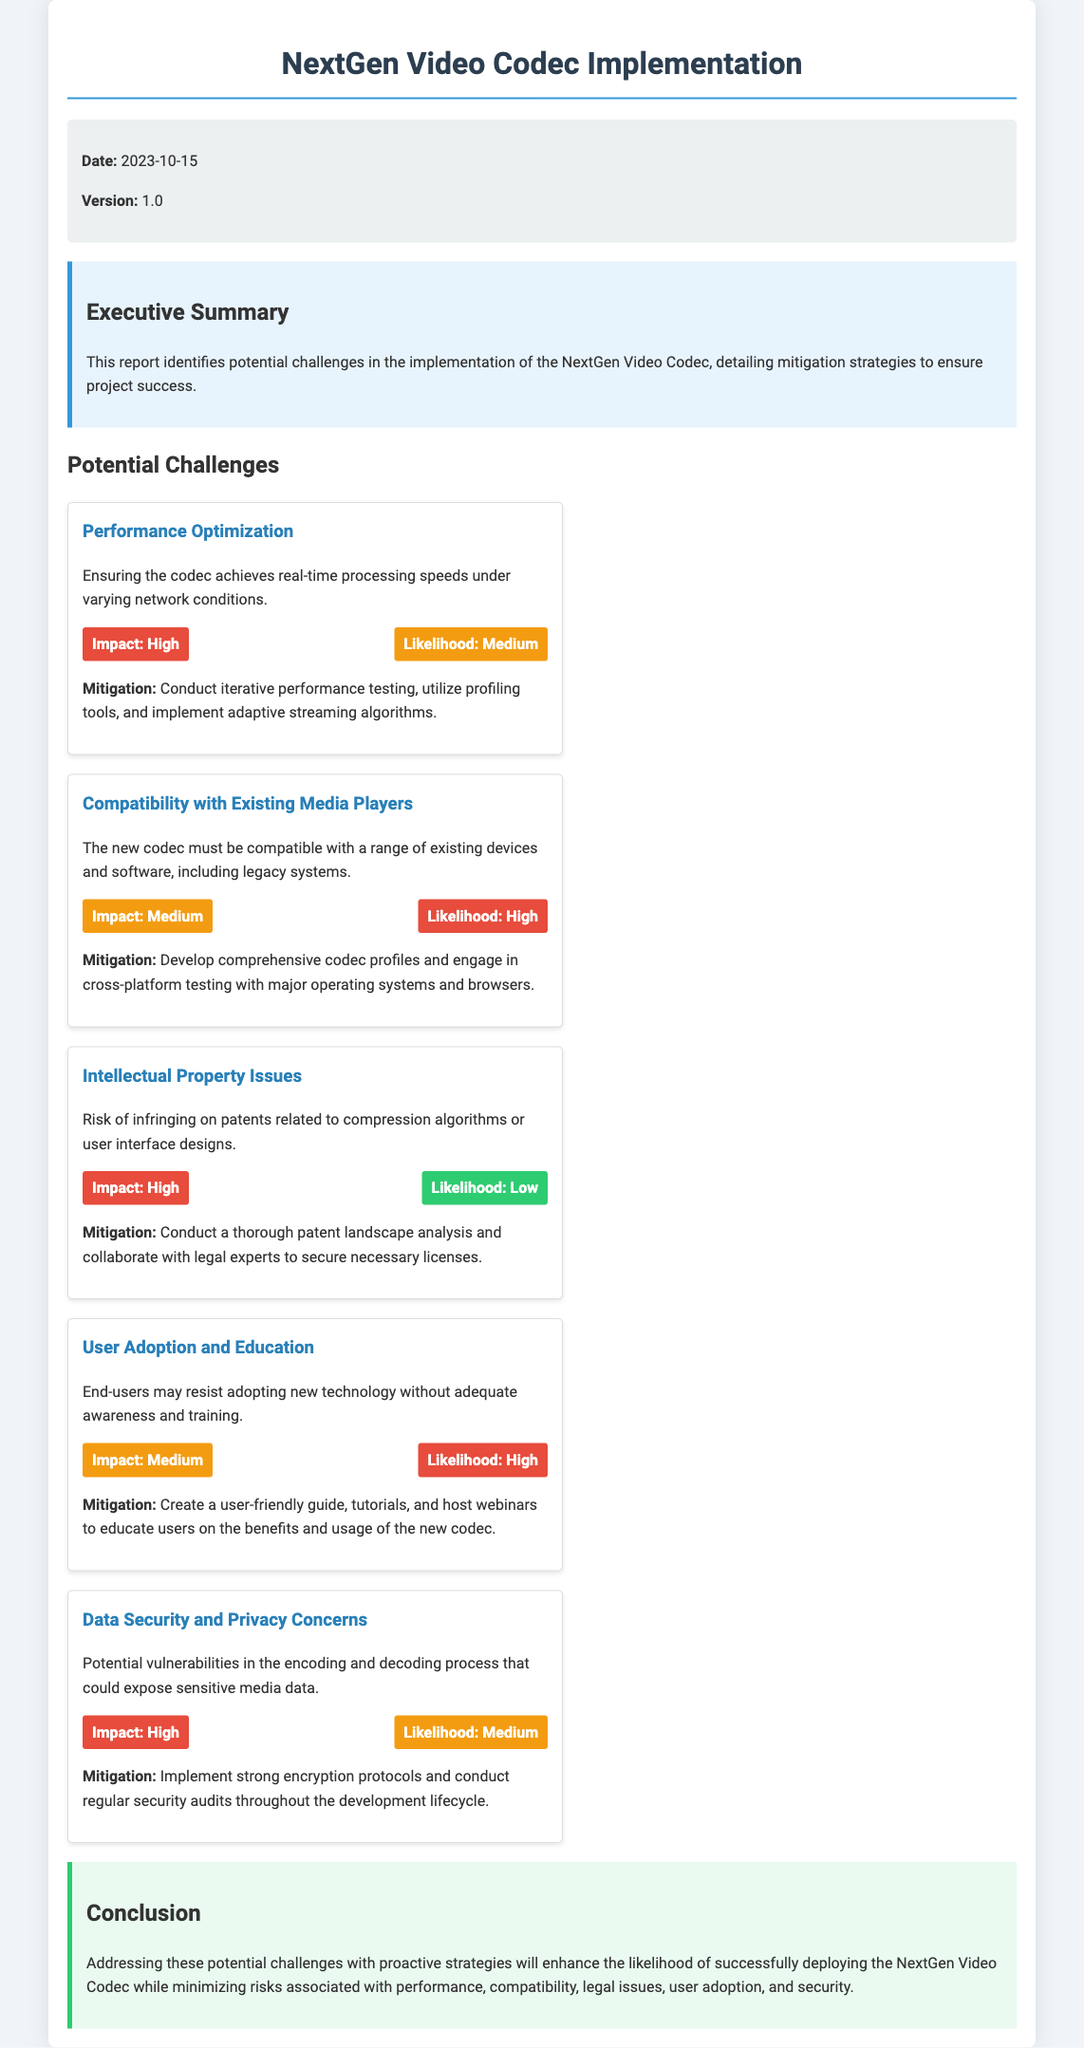What is the date of the report? The date of the report is stated in the project info section.
Answer: 2023-10-15 What is the version number of the report? The version number is mentioned in the project info section as well.
Answer: 1.0 What is the impact level of "Performance Optimization"? The impact level is highlighted in the challenge card for Performance Optimization.
Answer: High What is the mitigation strategy for "User Adoption and Education"? The mitigation strategy is listed under the relevant challenge card for User Adoption and Education.
Answer: Create a user-friendly guide, tutorials, and host webinars What is the likelihood of "Intellectual Property Issues"? The likelihood is indicated in the impact-likelihood section of the Intellectual Property Issues challenge.
Answer: Low What is the main concern related to "Data Security and Privacy"? The main concern is described in the challenge card for Data Security and Privacy.
Answer: Potential vulnerabilities in the encoding and decoding process What is the likelihood of "Compatibility with Existing Media Players"? The likelihood is specified in the relevant challenge card.
Answer: High What section details the summary of the report? The section that outlines the summary of the report is clearly identified in the structure of the document.
Answer: Executive Summary What kind of analysis is suggested for mitigating "Intellectual Property Issues"? The type of analysis to be conducted is mentioned as a part of the mitigation strategy.
Answer: Patent landscape analysis 